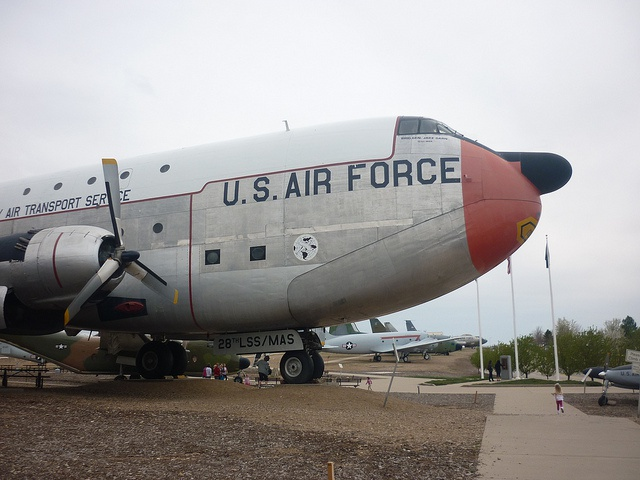Describe the objects in this image and their specific colors. I can see airplane in lightgray, darkgray, black, and gray tones, airplane in lightgray, darkgray, gray, and black tones, airplane in lightgray, gray, darkgray, black, and darkgreen tones, airplane in lightgray, black, and gray tones, and people in lightgray, black, and purple tones in this image. 